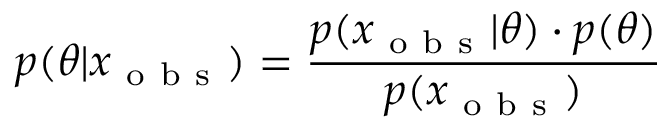<formula> <loc_0><loc_0><loc_500><loc_500>p ( \theta | x _ { o b s } ) = \frac { p ( x _ { o b s } | \theta ) \cdot p ( \theta ) } { p ( x _ { o b s } ) }</formula> 